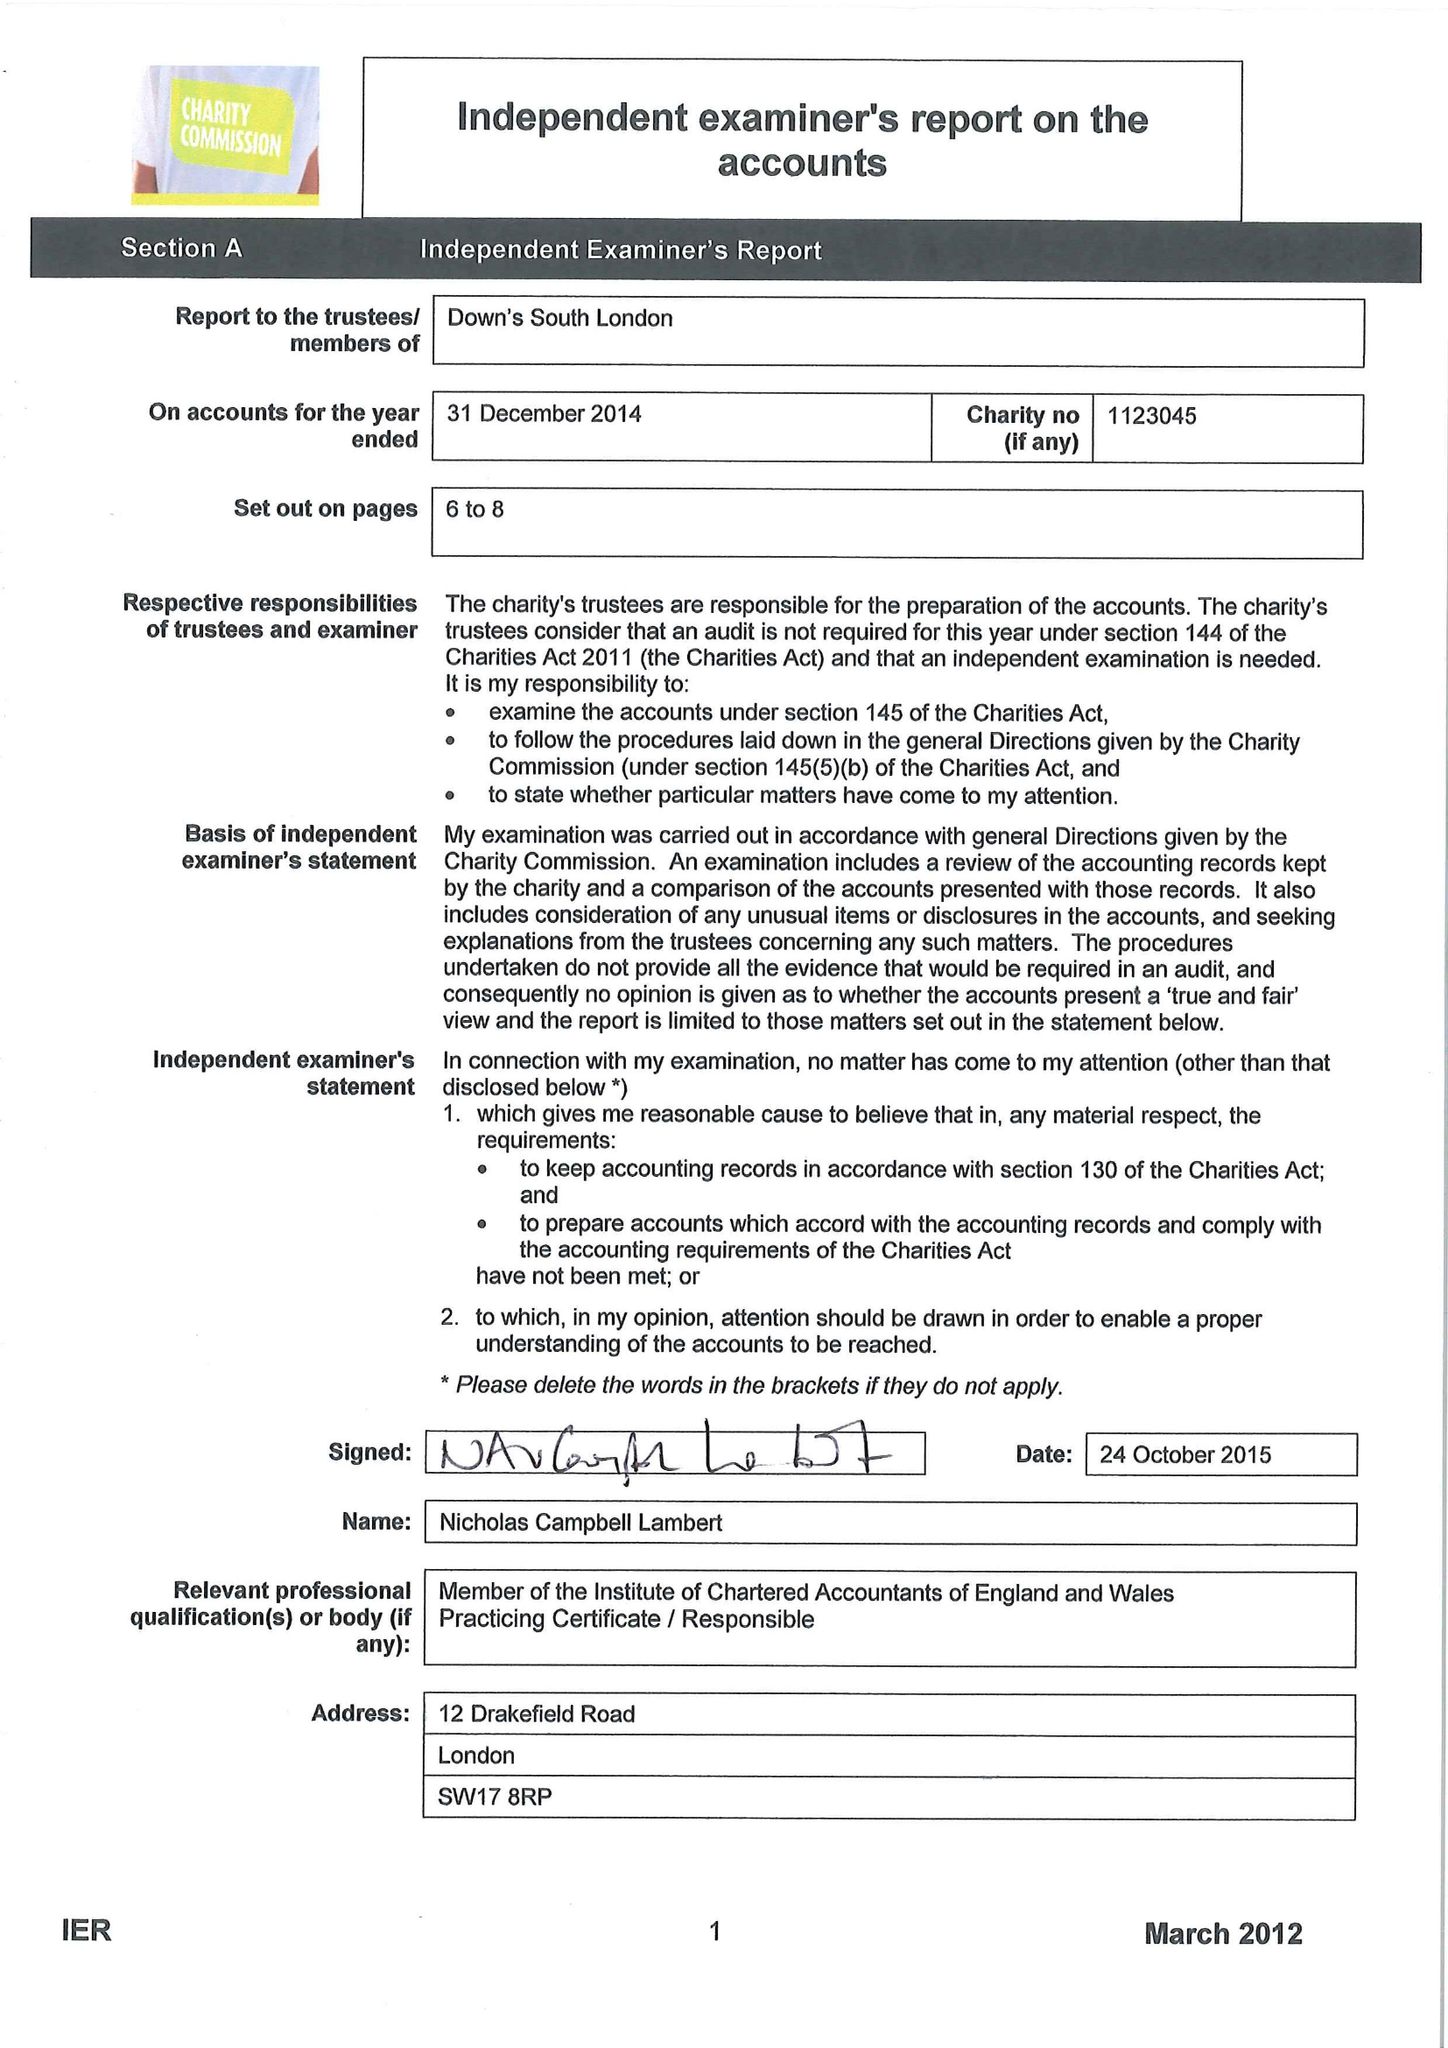What is the value for the income_annually_in_british_pounds?
Answer the question using a single word or phrase. 133523.00 